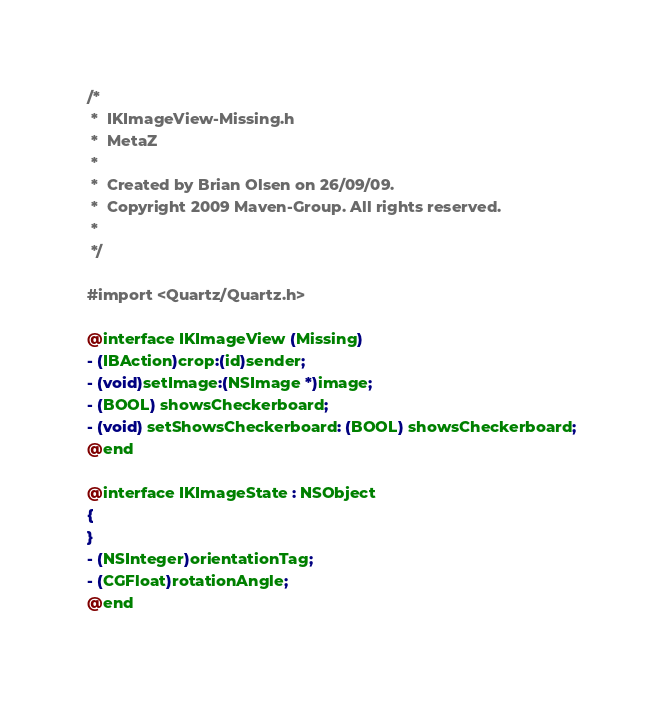<code> <loc_0><loc_0><loc_500><loc_500><_C_>/*
 *  IKImageView-Missing.h
 *  MetaZ
 *
 *  Created by Brian Olsen on 26/09/09.
 *  Copyright 2009 Maven-Group. All rights reserved.
 *
 */

#import <Quartz/Quartz.h>

@interface IKImageView (Missing)
- (IBAction)crop:(id)sender;
- (void)setImage:(NSImage *)image;
- (BOOL) showsCheckerboard;
- (void) setShowsCheckerboard: (BOOL) showsCheckerboard;
@end

@interface IKImageState : NSObject
{
}
- (NSInteger)orientationTag;
- (CGFloat)rotationAngle;
@end

</code> 